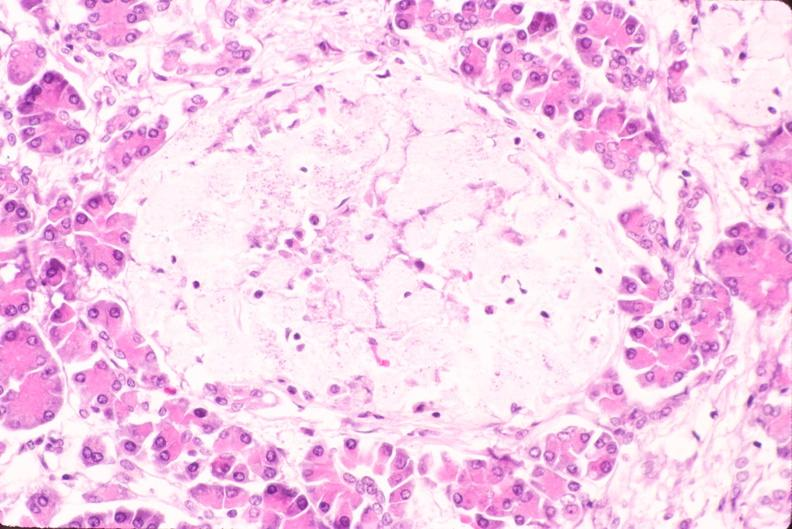where is this part in the figure?
Answer the question using a single word or phrase. Endocrine system 